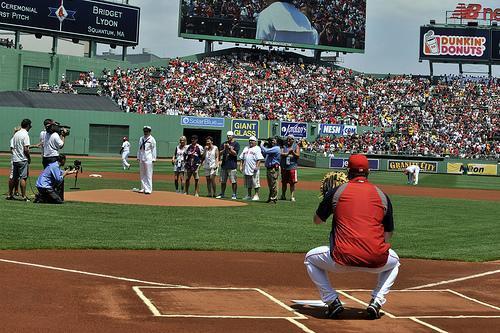How many people are on the pitcher's mound?
Give a very brief answer. 1. 